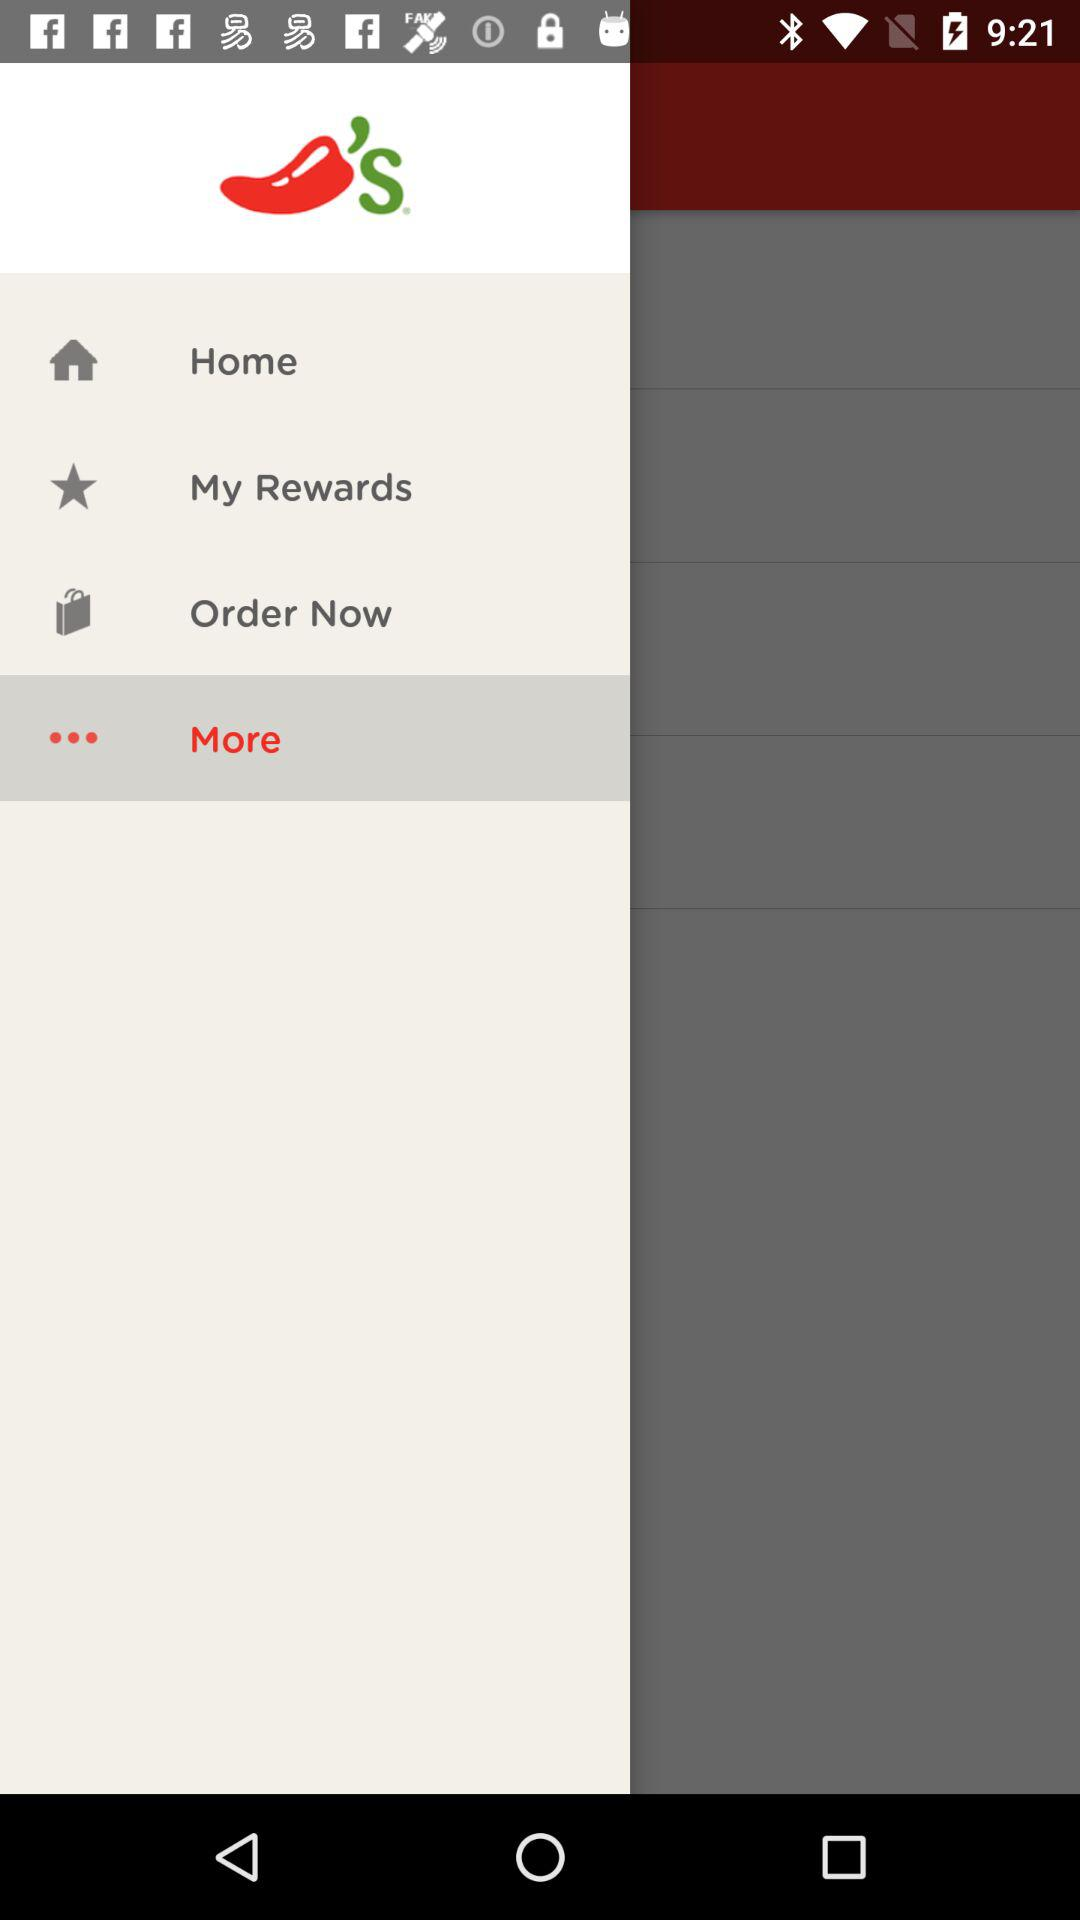What is the selected option? The selected option is "More". 